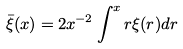<formula> <loc_0><loc_0><loc_500><loc_500>\bar { \xi } ( x ) = 2 x ^ { - 2 } \int ^ { x } r \xi ( r ) d r</formula> 